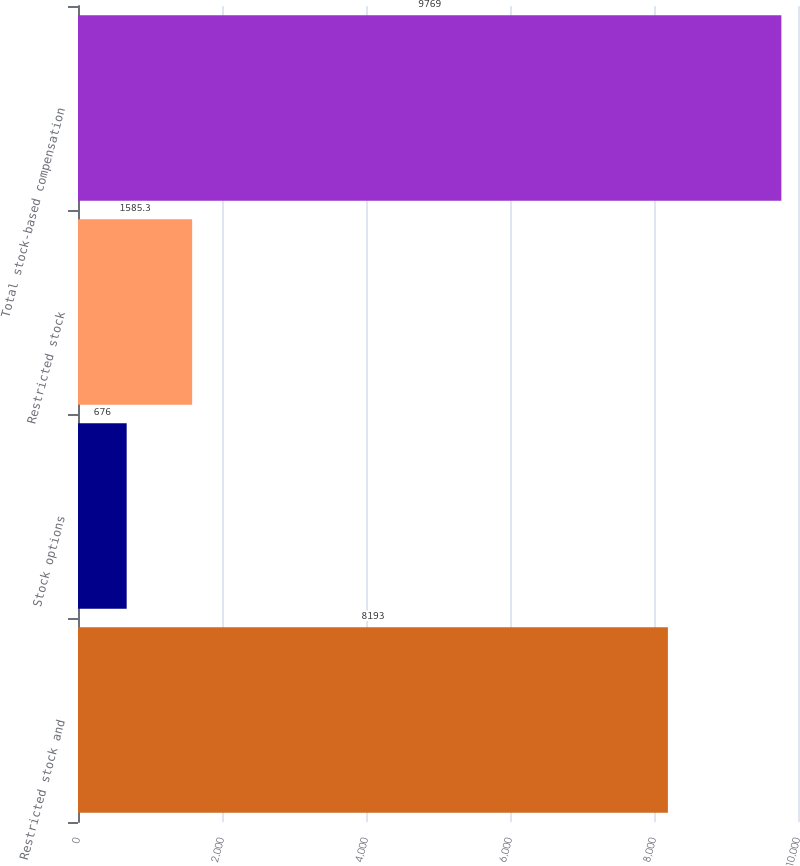Convert chart. <chart><loc_0><loc_0><loc_500><loc_500><bar_chart><fcel>Restricted stock and<fcel>Stock options<fcel>Restricted stock<fcel>Total stock-based compensation<nl><fcel>8193<fcel>676<fcel>1585.3<fcel>9769<nl></chart> 